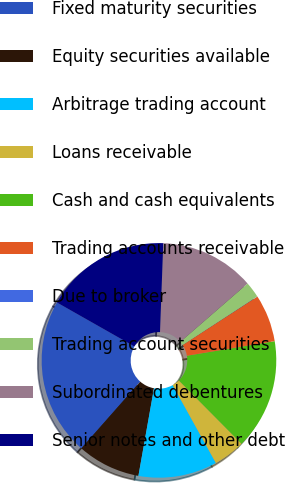<chart> <loc_0><loc_0><loc_500><loc_500><pie_chart><fcel>Fixed maturity securities<fcel>Equity securities available<fcel>Arbitrage trading account<fcel>Loans receivable<fcel>Cash and cash equivalents<fcel>Trading accounts receivable<fcel>Due to broker<fcel>Trading account securities<fcel>Subordinated debentures<fcel>Senior notes and other debt<nl><fcel>21.71%<fcel>8.7%<fcel>10.87%<fcel>4.36%<fcel>15.2%<fcel>6.53%<fcel>0.03%<fcel>2.19%<fcel>13.04%<fcel>17.37%<nl></chart> 